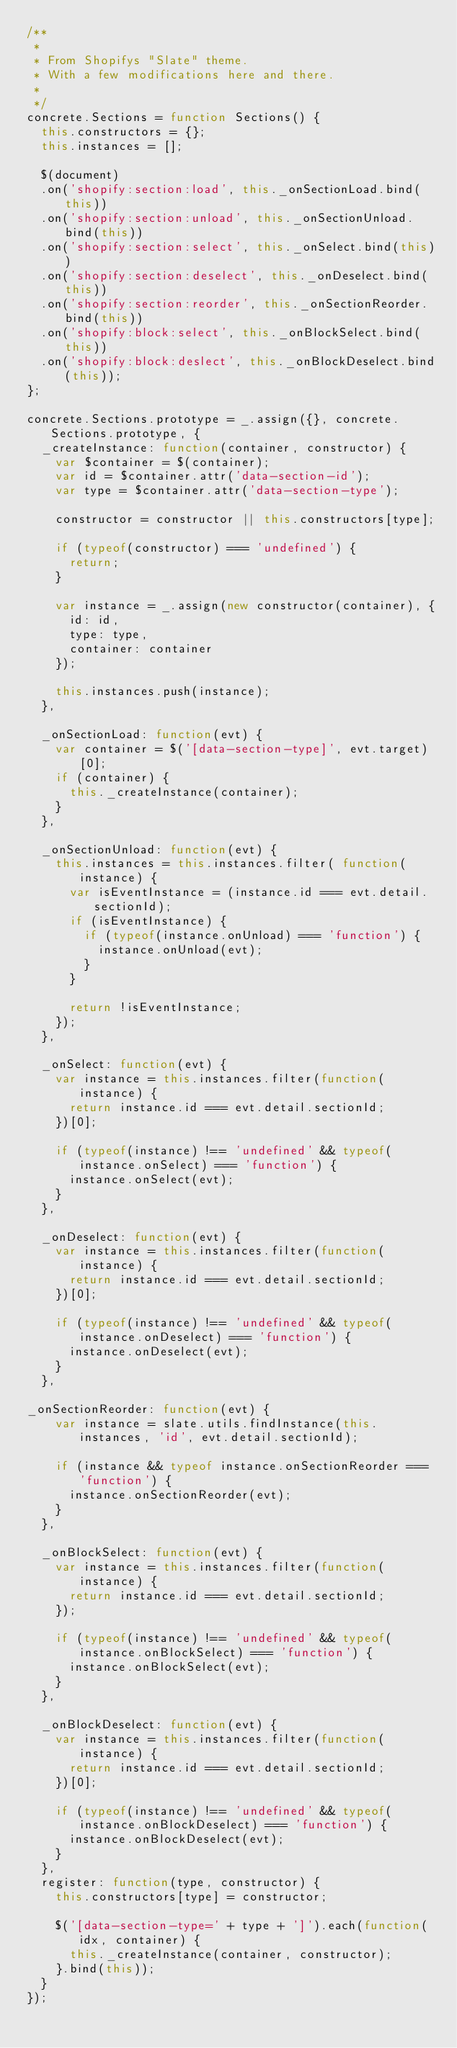<code> <loc_0><loc_0><loc_500><loc_500><_JavaScript_>/**
 *
 * From Shopifys "Slate" theme.
 * With a few modifications here and there.
 *
 */
concrete.Sections = function Sections() {
  this.constructors = {};
  this.instances = [];

  $(document)
  .on('shopify:section:load', this._onSectionLoad.bind(this))
  .on('shopify:section:unload', this._onSectionUnload.bind(this))
  .on('shopify:section:select', this._onSelect.bind(this))
  .on('shopify:section:deselect', this._onDeselect.bind(this))
  .on('shopify:section:reorder', this._onSectionReorder.bind(this))
  .on('shopify:block:select', this._onBlockSelect.bind(this))
  .on('shopify:block:deslect', this._onBlockDeselect.bind(this));
};

concrete.Sections.prototype = _.assign({}, concrete.Sections.prototype, {
  _createInstance: function(container, constructor) {
    var $container = $(container);
    var id = $container.attr('data-section-id');
    var type = $container.attr('data-section-type');

    constructor = constructor || this.constructors[type];

    if (typeof(constructor) === 'undefined') {
      return;
    }

    var instance = _.assign(new constructor(container), {
      id: id,
      type: type,
      container: container
    });

    this.instances.push(instance);
  },

  _onSectionLoad: function(evt) {
    var container = $('[data-section-type]', evt.target)[0];
    if (container) {
      this._createInstance(container);
    }
  },

  _onSectionUnload: function(evt) {
    this.instances = this.instances.filter( function(instance) {
      var isEventInstance = (instance.id === evt.detail.sectionId);
      if (isEventInstance) {
        if (typeof(instance.onUnload) === 'function') {
          instance.onUnload(evt);
        }
      }

      return !isEventInstance;
    });
  },

  _onSelect: function(evt) {
    var instance = this.instances.filter(function(instance) {
      return instance.id === evt.detail.sectionId;
    })[0];

    if (typeof(instance) !== 'undefined' && typeof(instance.onSelect) === 'function') {
      instance.onSelect(evt);
    }
  },

  _onDeselect: function(evt) {
    var instance = this.instances.filter(function(instance) {
      return instance.id === evt.detail.sectionId;
    })[0];

    if (typeof(instance) !== 'undefined' && typeof(instance.onDeselect) === 'function') {
      instance.onDeselect(evt);
    }
  },

_onSectionReorder: function(evt) {
    var instance = slate.utils.findInstance(this.instances, 'id', evt.detail.sectionId);

    if (instance && typeof instance.onSectionReorder === 'function') {
      instance.onSectionReorder(evt);
    }
  },

  _onBlockSelect: function(evt) {
    var instance = this.instances.filter(function(instance) {
      return instance.id === evt.detail.sectionId;
    });

    if (typeof(instance) !== 'undefined' && typeof(instance.onBlockSelect) === 'function') {
      instance.onBlockSelect(evt);
    }
  },

  _onBlockDeselect: function(evt) {
    var instance = this.instances.filter(function(instance) {
      return instance.id === evt.detail.sectionId;
    })[0];

    if (typeof(instance) !== 'undefined' && typeof(instance.onBlockDeselect) === 'function') {
      instance.onBlockDeselect(evt);
    }
  },
  register: function(type, constructor) {
    this.constructors[type] = constructor;

    $('[data-section-type=' + type + ']').each(function(idx, container) {
      this._createInstance(container, constructor);
    }.bind(this));
  }
});
</code> 